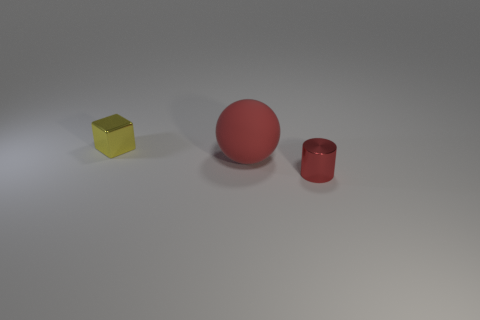Add 3 cyan things. How many objects exist? 6 Subtract all cubes. How many objects are left? 2 Add 3 small cylinders. How many small cylinders are left? 4 Add 2 green metallic blocks. How many green metallic blocks exist? 2 Subtract 1 red spheres. How many objects are left? 2 Subtract all large purple metallic cylinders. Subtract all tiny red shiny things. How many objects are left? 2 